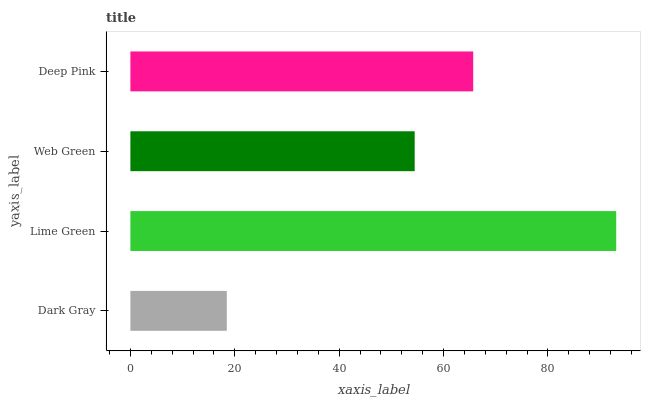Is Dark Gray the minimum?
Answer yes or no. Yes. Is Lime Green the maximum?
Answer yes or no. Yes. Is Web Green the minimum?
Answer yes or no. No. Is Web Green the maximum?
Answer yes or no. No. Is Lime Green greater than Web Green?
Answer yes or no. Yes. Is Web Green less than Lime Green?
Answer yes or no. Yes. Is Web Green greater than Lime Green?
Answer yes or no. No. Is Lime Green less than Web Green?
Answer yes or no. No. Is Deep Pink the high median?
Answer yes or no. Yes. Is Web Green the low median?
Answer yes or no. Yes. Is Dark Gray the high median?
Answer yes or no. No. Is Lime Green the low median?
Answer yes or no. No. 